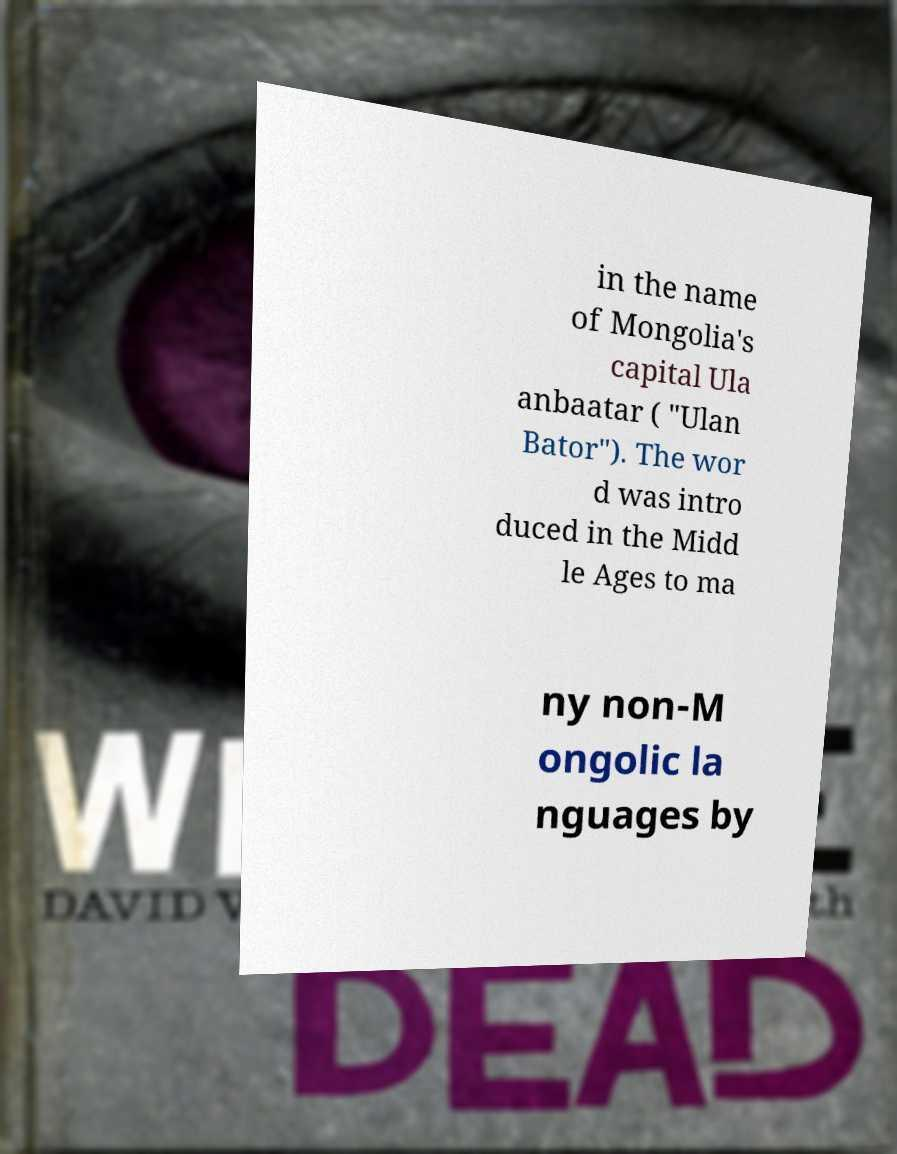Could you extract and type out the text from this image? in the name of Mongolia's capital Ula anbaatar ( "Ulan Bator"). The wor d was intro duced in the Midd le Ages to ma ny non-M ongolic la nguages by 